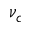Convert formula to latex. <formula><loc_0><loc_0><loc_500><loc_500>\nu _ { c }</formula> 